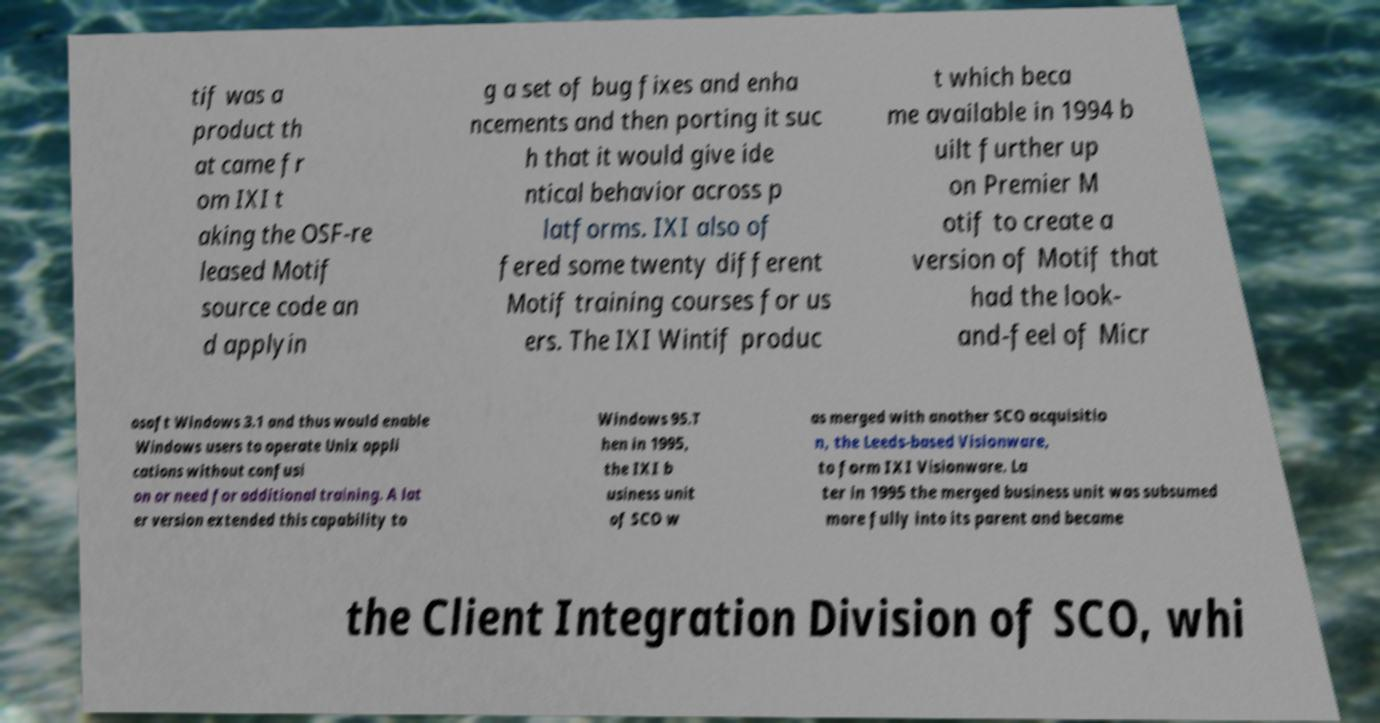I need the written content from this picture converted into text. Can you do that? tif was a product th at came fr om IXI t aking the OSF-re leased Motif source code an d applyin g a set of bug fixes and enha ncements and then porting it suc h that it would give ide ntical behavior across p latforms. IXI also of fered some twenty different Motif training courses for us ers. The IXI Wintif produc t which beca me available in 1994 b uilt further up on Premier M otif to create a version of Motif that had the look- and-feel of Micr osoft Windows 3.1 and thus would enable Windows users to operate Unix appli cations without confusi on or need for additional training. A lat er version extended this capability to Windows 95.T hen in 1995, the IXI b usiness unit of SCO w as merged with another SCO acquisitio n, the Leeds-based Visionware, to form IXI Visionware. La ter in 1995 the merged business unit was subsumed more fully into its parent and became the Client Integration Division of SCO, whi 